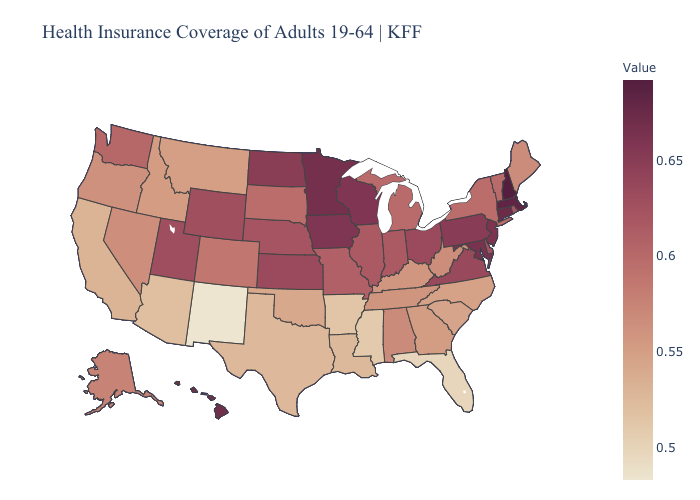Does Hawaii have the highest value in the West?
Be succinct. Yes. Among the states that border Vermont , which have the highest value?
Concise answer only. New Hampshire. Among the states that border Kansas , which have the lowest value?
Concise answer only. Oklahoma. Which states have the highest value in the USA?
Short answer required. New Hampshire. 